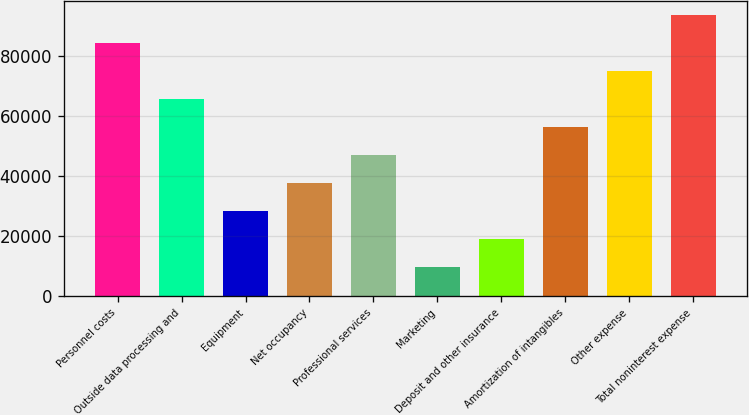Convert chart. <chart><loc_0><loc_0><loc_500><loc_500><bar_chart><fcel>Personnel costs<fcel>Outside data processing and<fcel>Equipment<fcel>Net occupancy<fcel>Professional services<fcel>Marketing<fcel>Deposit and other insurance<fcel>Amortization of intangibles<fcel>Other expense<fcel>Total noninterest expense<nl><fcel>84242.8<fcel>65604.4<fcel>28327.6<fcel>37646.8<fcel>46966<fcel>9689.2<fcel>19008.4<fcel>56285.2<fcel>74923.6<fcel>93562<nl></chart> 